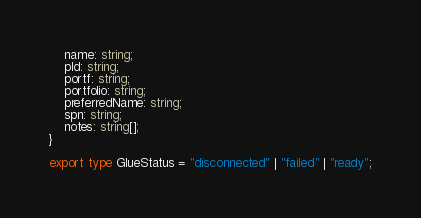<code> <loc_0><loc_0><loc_500><loc_500><_TypeScript_>    name: string;
    pId: string;
    portf: string;
    portfolio: string;
    preferredName: string;
    spn: string;
    notes: string[];
}

export type GlueStatus = "disconnected" | "failed" | "ready";</code> 